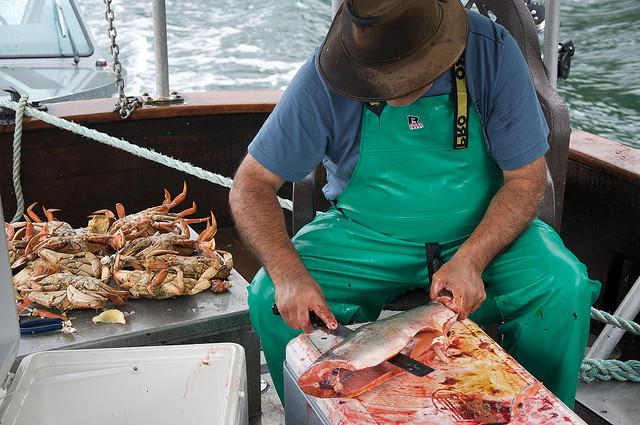Where is this?
Give a very brief answer. Boat. Are there more than one species of animal in this photo?
Short answer required. Yes. What is the man cutting?
Short answer required. Fish. 